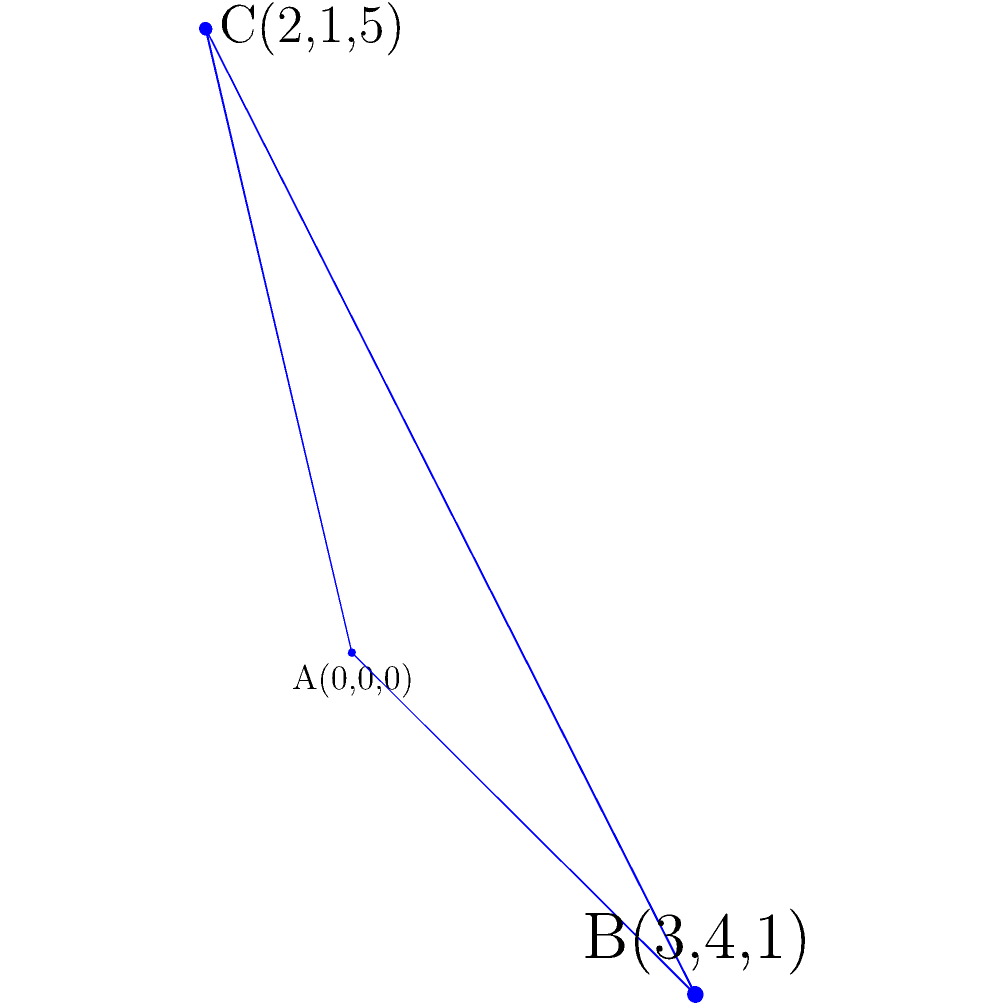Given three points in space that represent an aircraft's position at different times: A(0,0,0), B(3,4,1), and C(2,1,5), find the equation of the plane that represents the aircraft's flight path. To find the equation of a plane given three points, we can follow these steps:

1) The general equation of a plane is $Ax + By + Cz + D = 0$, where (A,B,C) is the normal vector to the plane.

2) We can find two vectors on the plane:
   $\vec{AB} = (3-0, 4-0, 1-0) = (3, 4, 1)$
   $\vec{AC} = (2-0, 1-0, 5-0) = (2, 1, 5)$

3) The normal vector to the plane is the cross product of these vectors:
   $\vec{n} = \vec{AB} \times \vec{AC} = \begin{vmatrix} 
   i & j & k \\
   3 & 4 & 1 \\
   2 & 1 & 5
   \end{vmatrix}$

4) Calculating the determinant:
   $\vec{n} = (4\cdot5 - 1\cdot1)i - (3\cdot5 - 1\cdot2)j + (3\cdot1 - 4\cdot2)k$
   $\vec{n} = 19i - 13j - 5k$

5) So, the equation of the plane is:
   $19x - 13y - 5z + D = 0$

6) To find D, we can substitute the coordinates of any point, let's use A(0,0,0):
   $19(0) - 13(0) - 5(0) + D = 0$
   $D = 0$

Therefore, the equation of the plane is $19x - 13y - 5z = 0$.
Answer: $19x - 13y - 5z = 0$ 